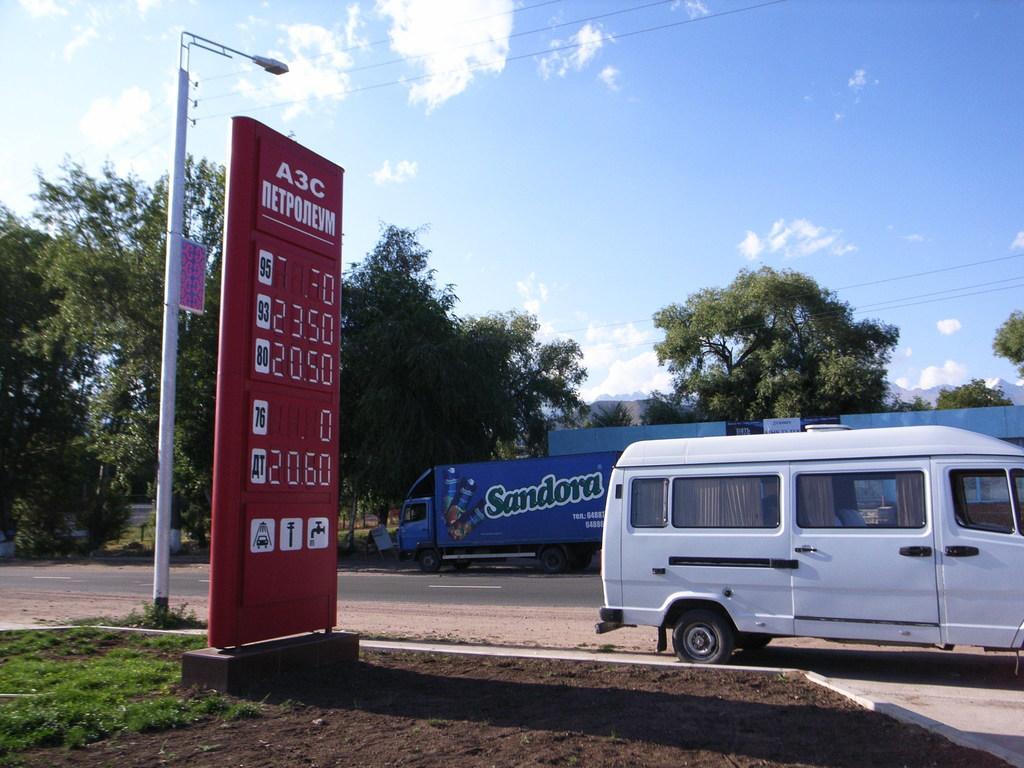Describe this image in one or two sentences. In the image there is a truck going on the road on right side and there is a ad board in the middle of grassland with a street light behind it, in the back there are trees, and above its sky with clouds. 